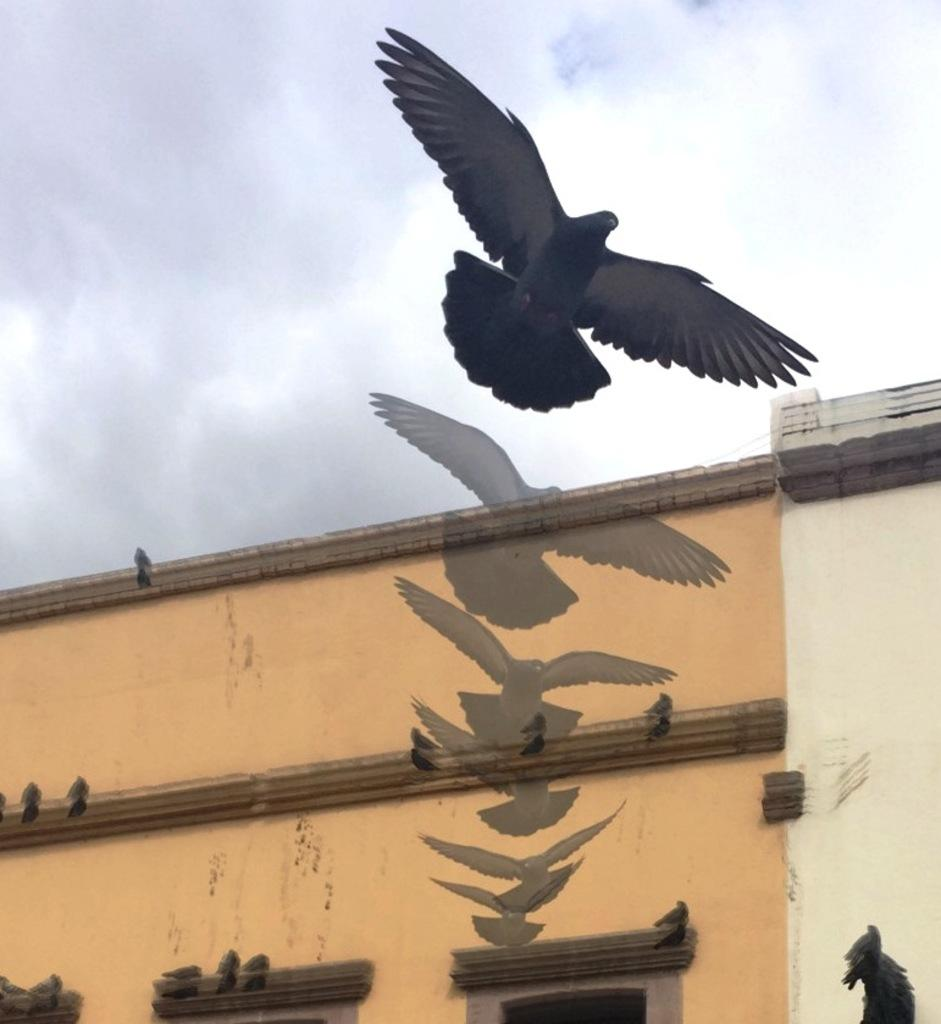What is the main subject of the image? The main subject of the image is a bird flying. What else can be seen in the image besides the bird? There is a building in the image, and some birds are present on the building. What is visible in the background of the image? The sky is visible in the background of the image, and clouds are present in the sky. What shape is the creator of the birds in the image? There is no mention of a creator in the image, so we cannot determine the shape of any such entity. 